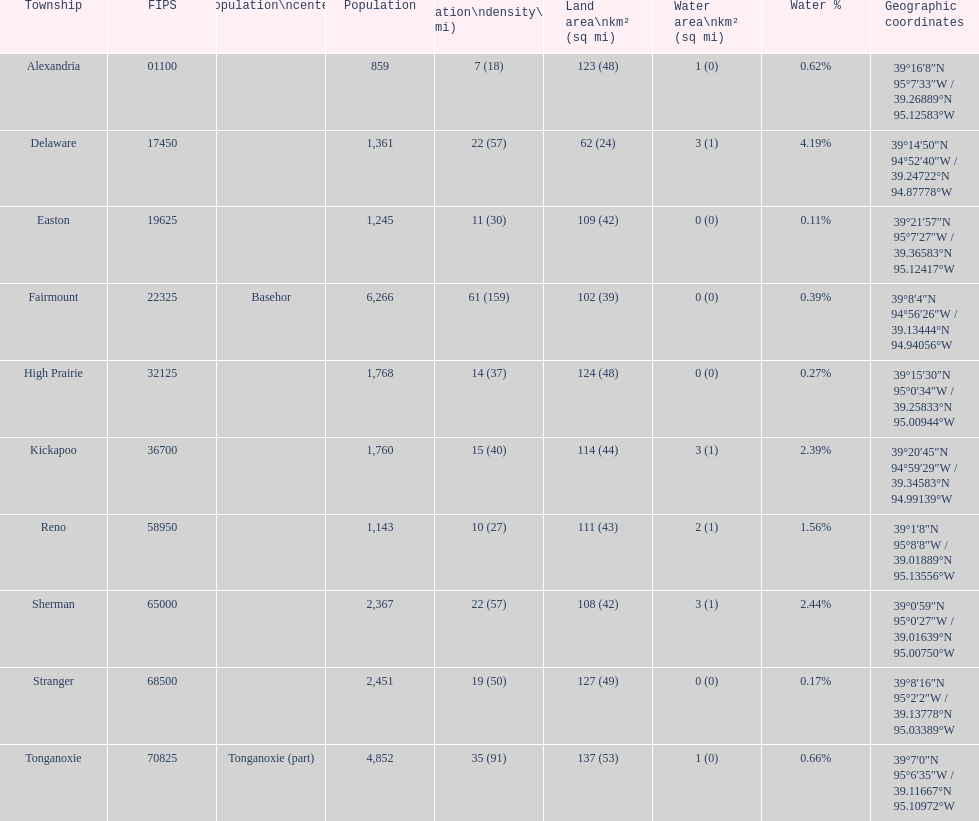What township has the most land area? Tonganoxie. 